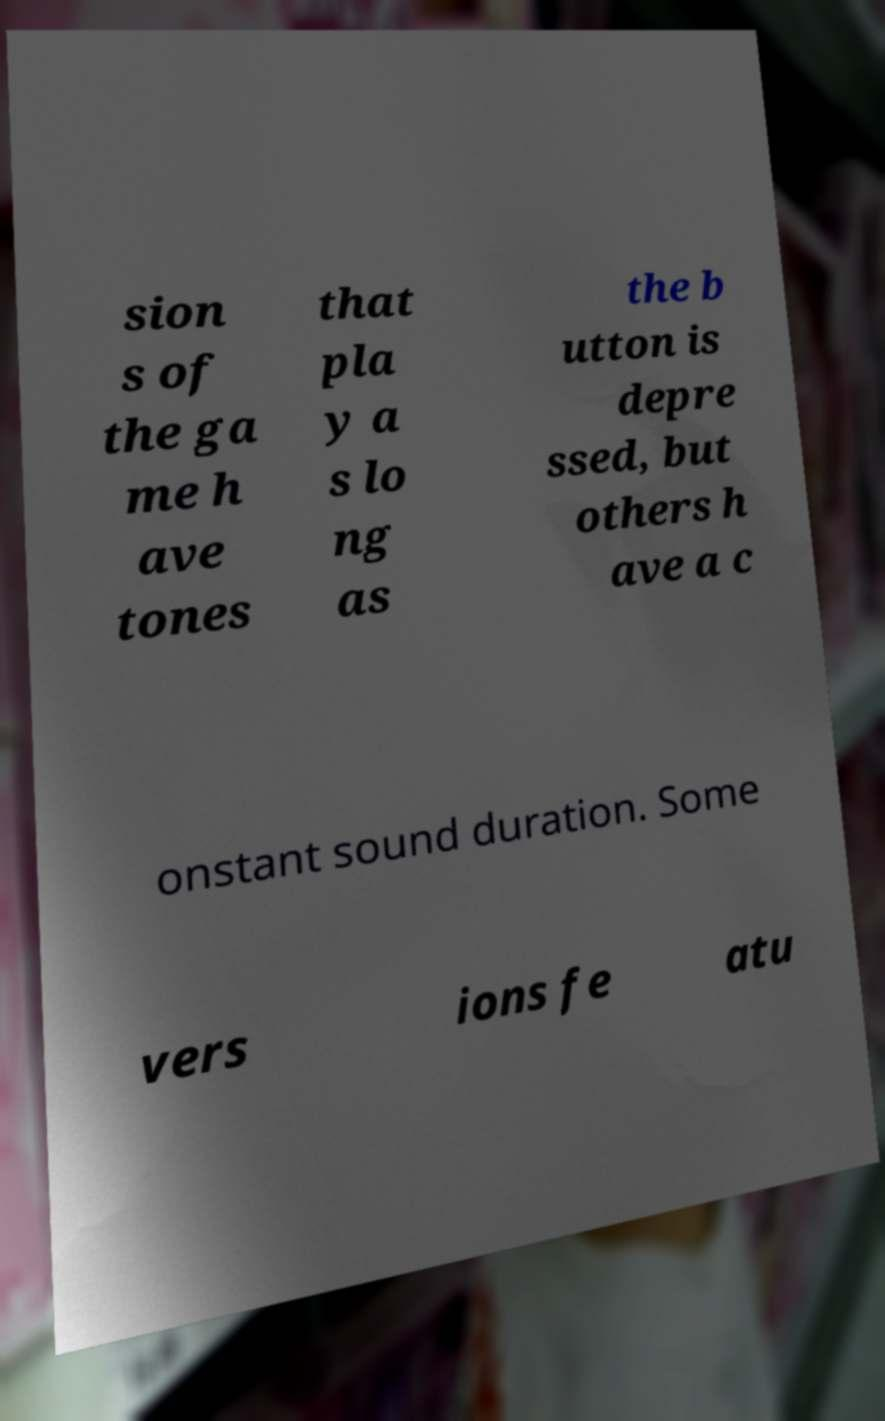I need the written content from this picture converted into text. Can you do that? sion s of the ga me h ave tones that pla y a s lo ng as the b utton is depre ssed, but others h ave a c onstant sound duration. Some vers ions fe atu 